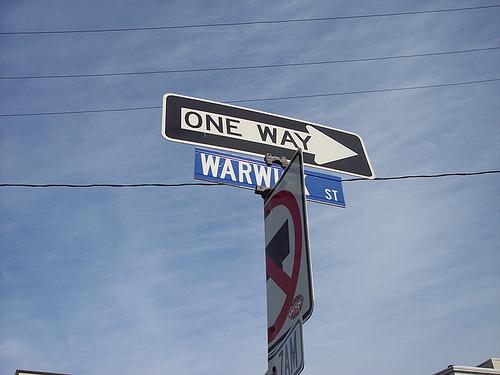Is it a two-way street?
Be succinct. No. How many colors are the signs?
Short answer required. 4. What did this sign originally say?
Concise answer only. One way. Are these Spanish street signs?
Write a very short answer. No. Where is the dead end?
Write a very short answer. Right. What lines are shown?
Answer briefly. Power. How many cables can you see?
Short answer required. 4. Which way is the arrow pointing?
Be succinct. Right. 